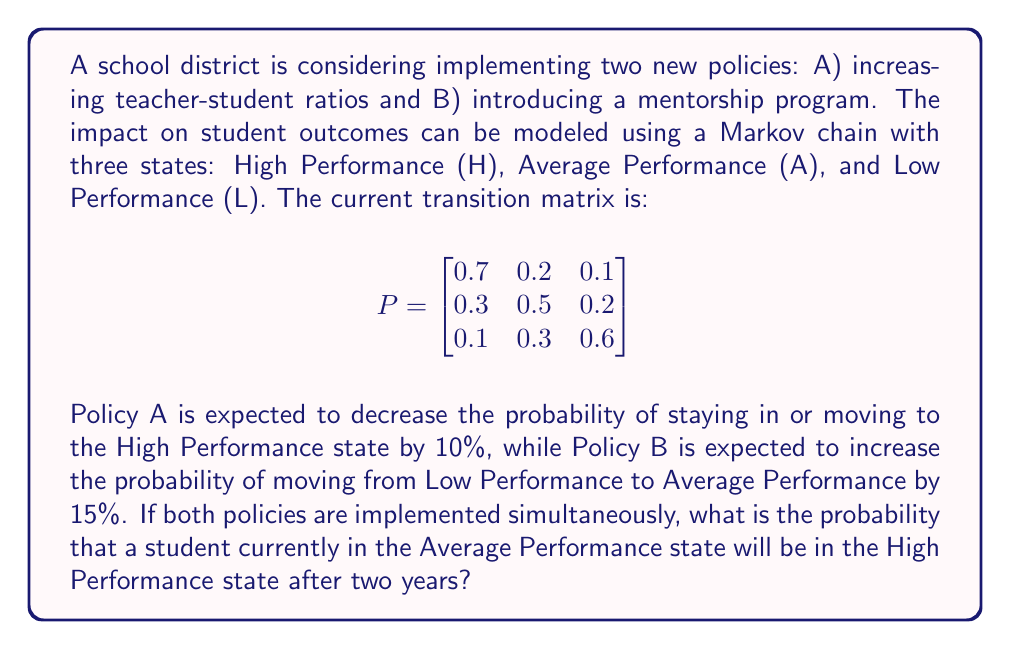Solve this math problem. Let's approach this step-by-step:

1) First, we need to create the new transition matrix after implementing both policies:

   For Policy A: Decrease probability of staying in or moving to H by 10%
   For Policy B: Increase probability of moving from L to A by 15%

   New matrix:
   $$
   P_{new} = \begin{bmatrix}
   0.63 & 0.26 & 0.11 \\
   0.27 & 0.5 & 0.23 \\
   0.1 & 0.45 & 0.45
   \end{bmatrix}
   $$

2) To find the probability after two years, we need to calculate $P_{new}^2$:

   $$
   P_{new}^2 = \begin{bmatrix}
   0.63 & 0.26 & 0.11 \\
   0.27 & 0.5 & 0.23 \\
   0.1 & 0.45 & 0.45
   \end{bmatrix} \times \begin{bmatrix}
   0.63 & 0.26 & 0.11 \\
   0.27 & 0.5 & 0.23 \\
   0.1 & 0.45 & 0.45
   \end{bmatrix}
   $$

3) Performing the matrix multiplication:

   $$
   P_{new}^2 = \begin{bmatrix}
   0.4977 & 0.3458 & 0.1565 \\
   0.3321 & 0.4115 & 0.2564 \\
   0.2403 & 0.4455 & 0.3142
   \end{bmatrix}
   $$

4) The question asks for the probability of a student currently in Average Performance (A) being in High Performance (H) after two years. This corresponds to the element in the second row, first column of $P_{new}^2$.

Therefore, the probability is 0.3321 or approximately 33.21%.
Answer: 0.3321 